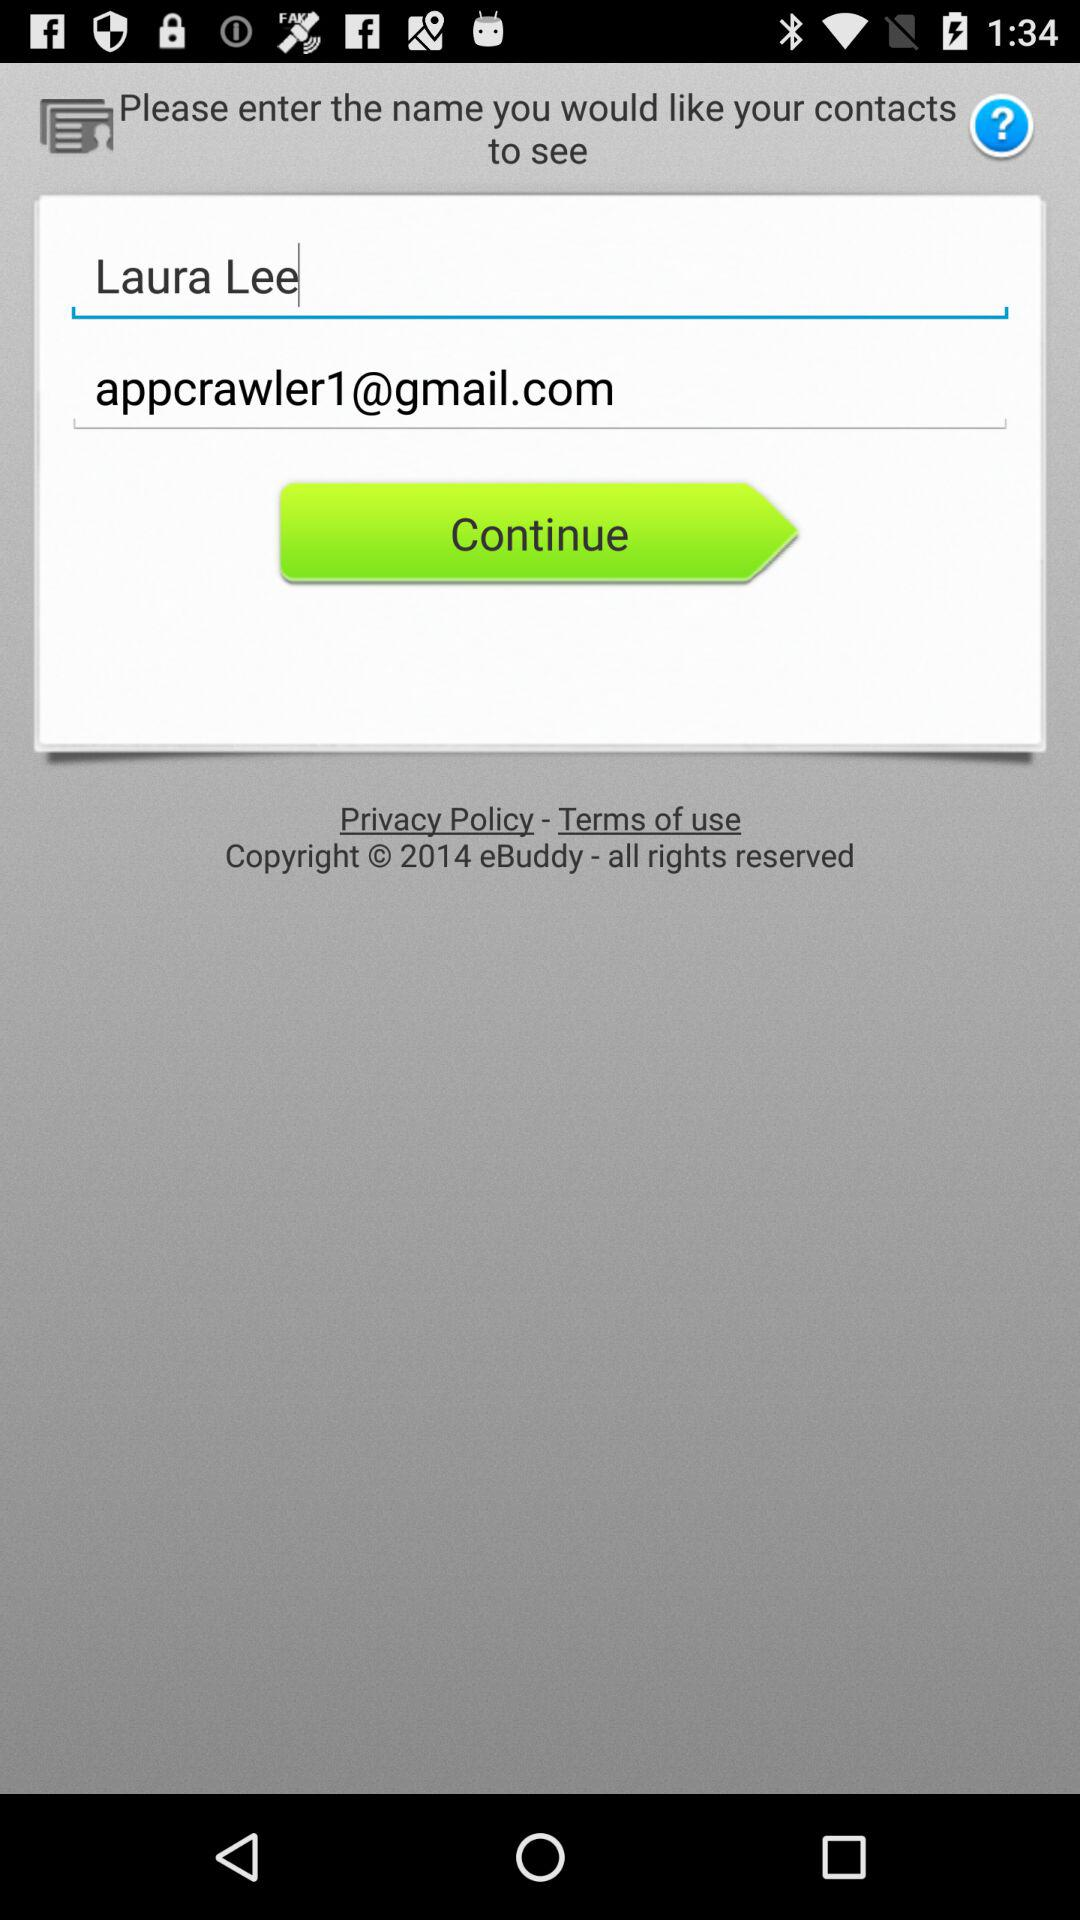What's the Google mail address? The mail address is appcrawler1@gmail.com. 